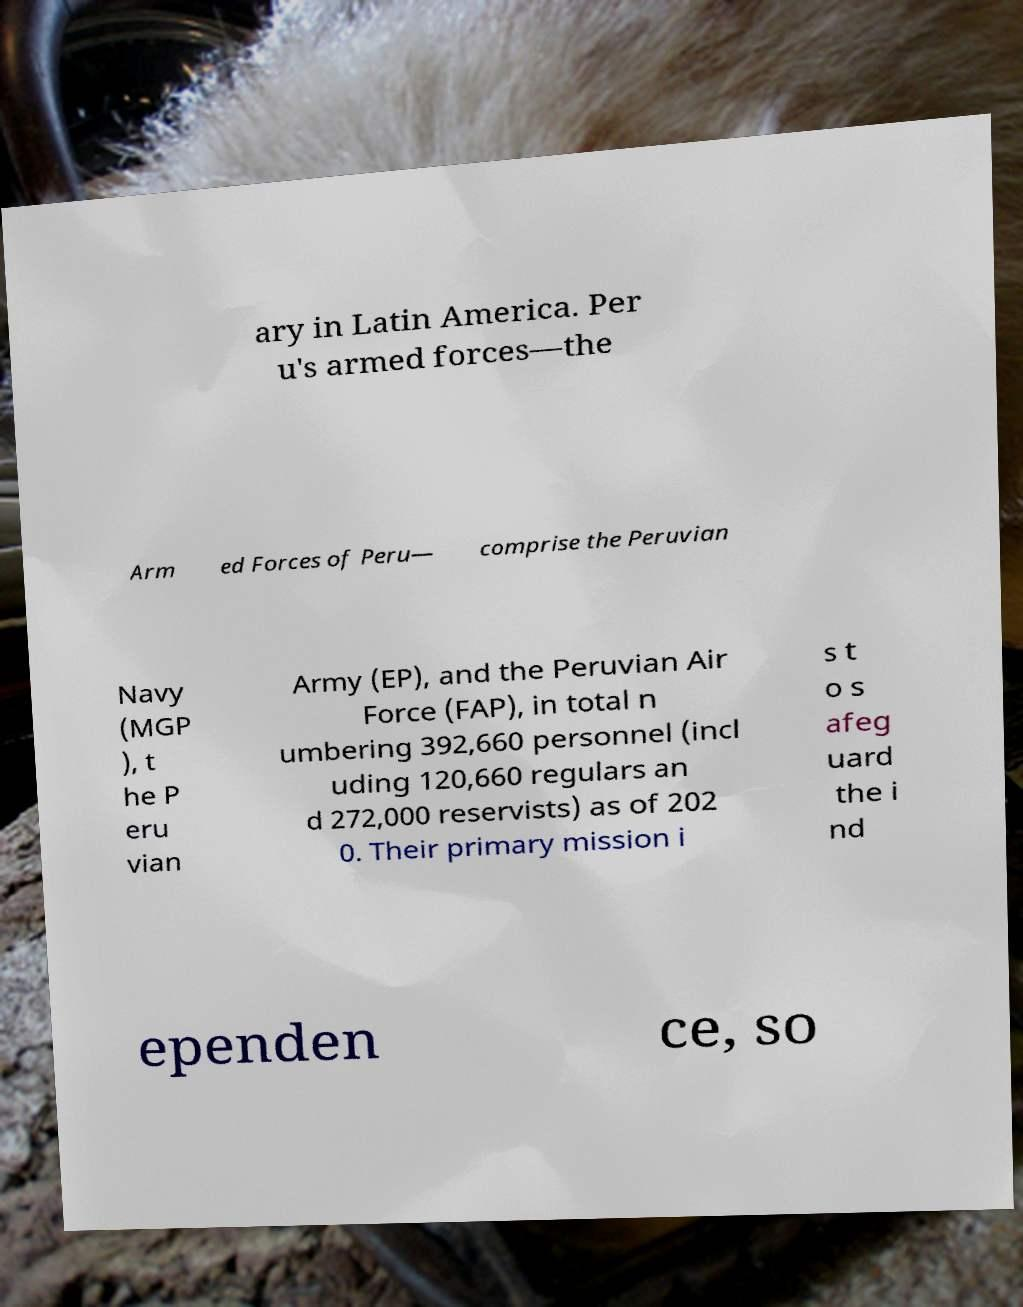There's text embedded in this image that I need extracted. Can you transcribe it verbatim? ary in Latin America. Per u's armed forces—the Arm ed Forces of Peru— comprise the Peruvian Navy (MGP ), t he P eru vian Army (EP), and the Peruvian Air Force (FAP), in total n umbering 392,660 personnel (incl uding 120,660 regulars an d 272,000 reservists) as of 202 0. Their primary mission i s t o s afeg uard the i nd ependen ce, so 